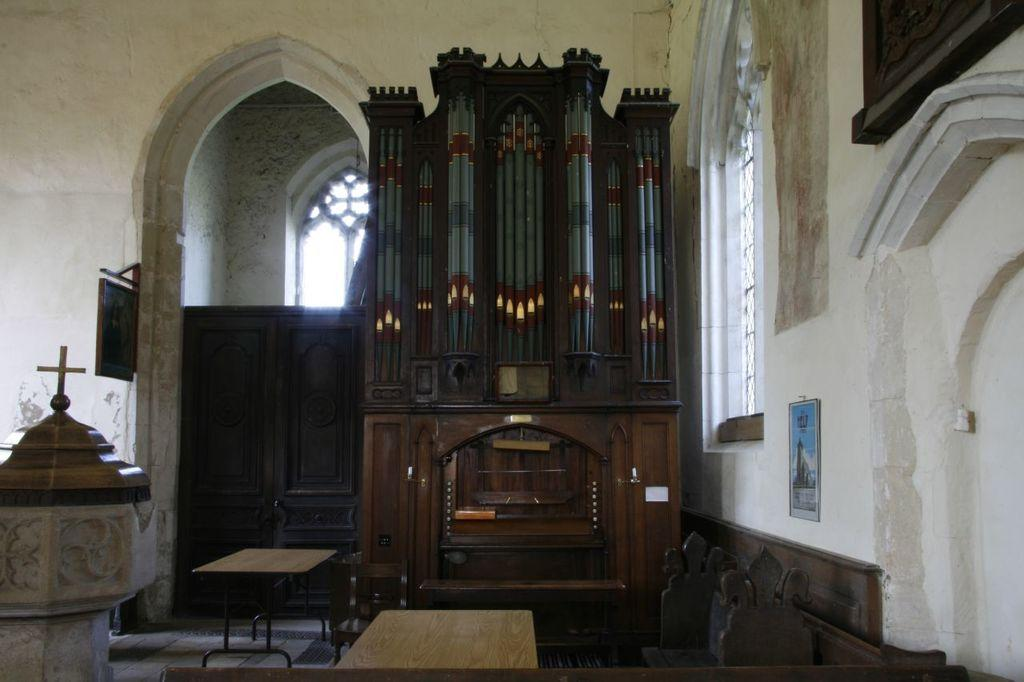How many tables can be seen in the image? There are two tables in the image. What is on one of the tables? There is a Christianity symbol on one of the tables. What is on the right side of the image? There is a wall on the right side of the image. What is hanging on the wall? There is a photo frame on the wall. What type of cup is being used for treatment on someone's toes in the image? There is no cup or treatment visible in the image, nor are there any toes present. 